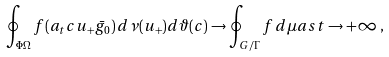<formula> <loc_0><loc_0><loc_500><loc_500>\oint _ { \Phi \Omega } f ( a _ { t } c u _ { + } \bar { g } _ { 0 } ) \, d \nu ( u _ { + } ) d \vartheta ( c ) \rightarrow \oint _ { G / \Gamma } f \, d \mu a s t \to + \infty \, ,</formula> 